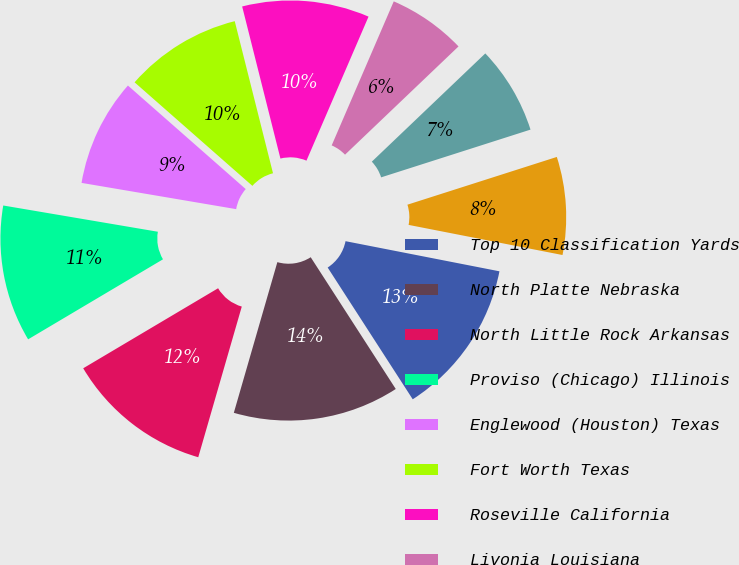Convert chart to OTSL. <chart><loc_0><loc_0><loc_500><loc_500><pie_chart><fcel>Top 10 Classification Yards<fcel>North Platte Nebraska<fcel>North Little Rock Arkansas<fcel>Proviso (Chicago) Illinois<fcel>Englewood (Houston) Texas<fcel>Fort Worth Texas<fcel>Roseville California<fcel>Livonia Louisiana<fcel>West Colton California<fcel>Pine Bluff Arkansas<nl><fcel>12.8%<fcel>13.6%<fcel>12.0%<fcel>11.2%<fcel>8.8%<fcel>9.6%<fcel>10.4%<fcel>6.4%<fcel>7.2%<fcel>8.0%<nl></chart> 